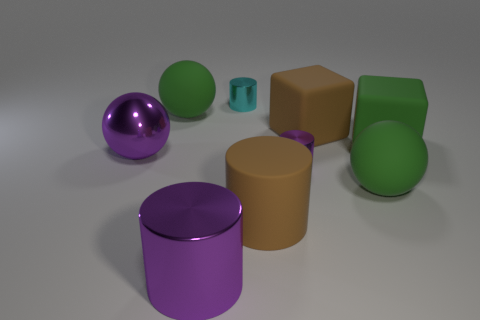Is the number of matte spheres in front of the big brown cylinder less than the number of cyan rubber balls?
Keep it short and to the point. No. Is there any other thing that is the same shape as the small purple shiny object?
Give a very brief answer. Yes. The other large matte object that is the same shape as the cyan object is what color?
Your response must be concise. Brown. Does the rubber object that is on the left side of the brown cylinder have the same size as the large shiny sphere?
Offer a very short reply. Yes. There is a matte block that is in front of the brown rubber thing to the right of the brown cylinder; what size is it?
Offer a very short reply. Large. Are the big green block and the green ball to the left of the cyan metallic thing made of the same material?
Give a very brief answer. Yes. Are there fewer big green blocks to the left of the green cube than green matte balls in front of the cyan object?
Ensure brevity in your answer.  Yes. What is the color of the large object that is made of the same material as the large purple sphere?
Offer a terse response. Purple. Is there a large matte ball right of the big rubber ball in front of the large purple shiny sphere?
Provide a succinct answer. No. What is the color of the metal sphere that is the same size as the brown matte cube?
Ensure brevity in your answer.  Purple. 